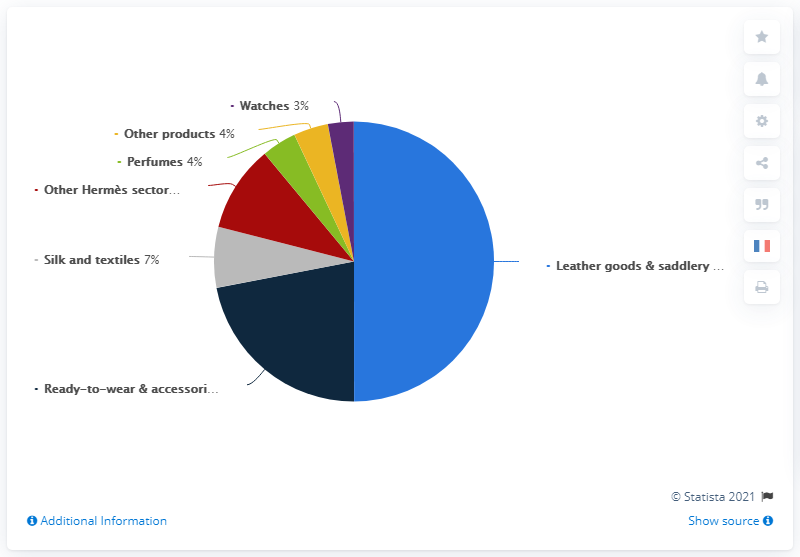Draw attention to some important aspects in this diagram. The leather goods and saddlery segment has the highest revenue share. The watch with the lowest percentage is [Watches, 3], and its value is [Watches, 3]. 